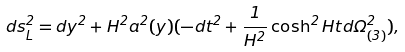Convert formula to latex. <formula><loc_0><loc_0><loc_500><loc_500>d s _ { L } ^ { 2 } = d y ^ { 2 } + H ^ { 2 } a ^ { 2 } ( y ) ( - d t ^ { 2 } + \frac { 1 } { H ^ { 2 } } \cosh ^ { 2 } H t d \Omega _ { ( 3 ) } ^ { 2 } ) ,</formula> 